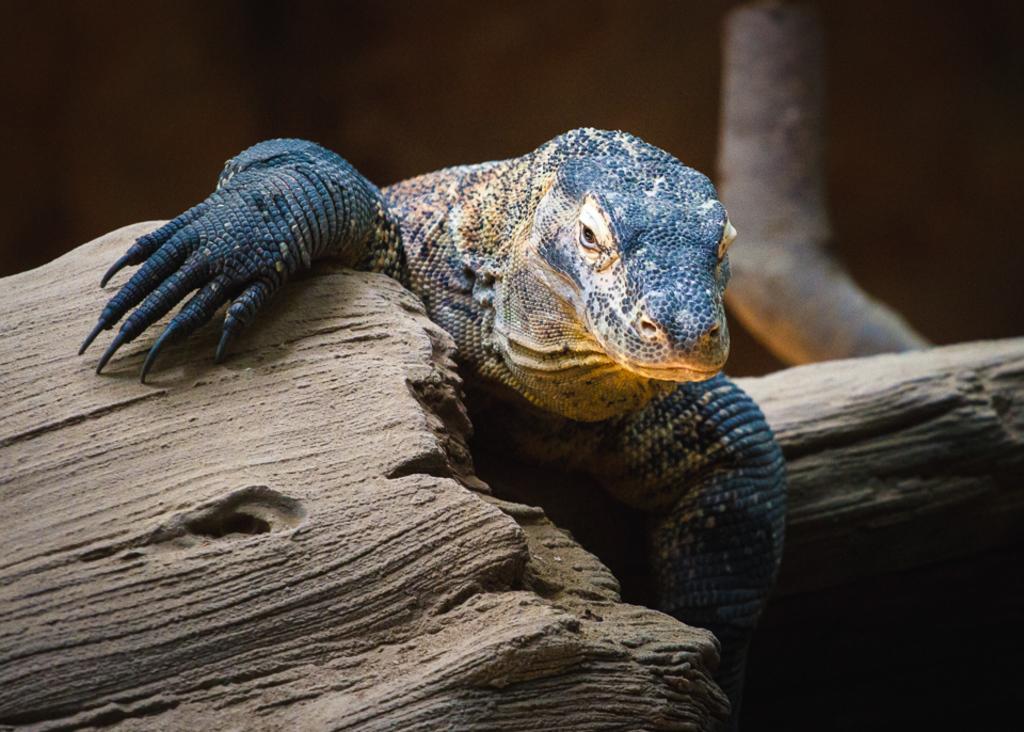Could you give a brief overview of what you see in this image? This image consists of an animal. It is in black color. 